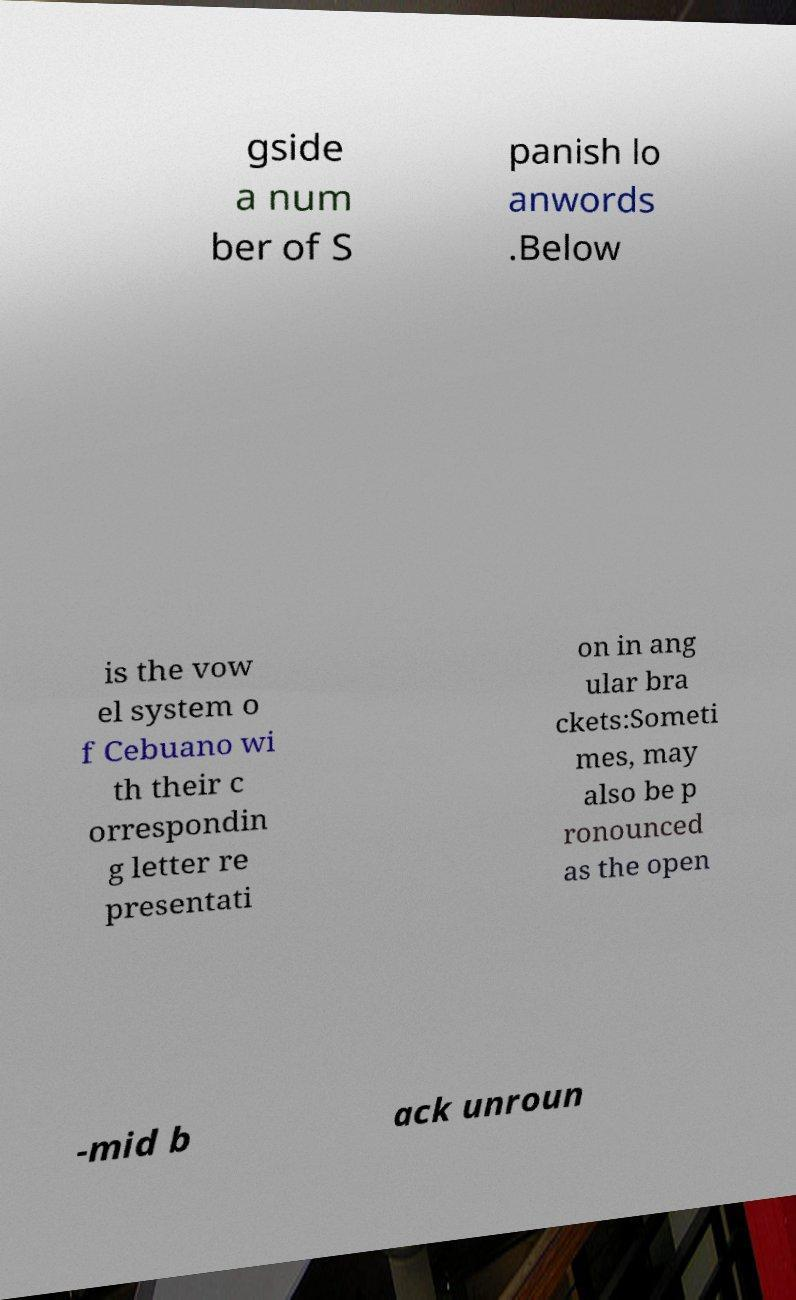I need the written content from this picture converted into text. Can you do that? gside a num ber of S panish lo anwords .Below is the vow el system o f Cebuano wi th their c orrespondin g letter re presentati on in ang ular bra ckets:Someti mes, may also be p ronounced as the open -mid b ack unroun 